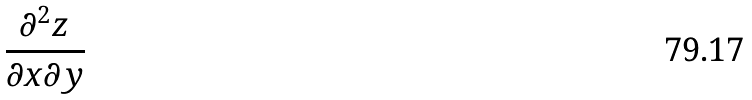<formula> <loc_0><loc_0><loc_500><loc_500>\frac { \partial ^ { 2 } z } { \partial x \partial y }</formula> 